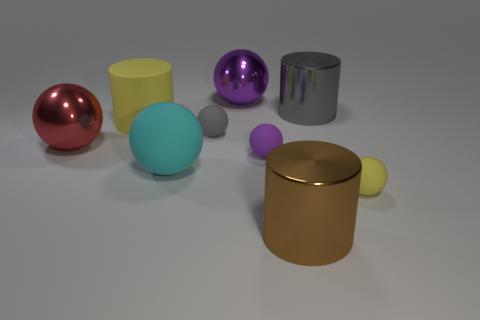Subtract all large rubber cylinders. How many cylinders are left? 2 Add 1 yellow matte things. How many objects exist? 10 Subtract 4 balls. How many balls are left? 2 Subtract all yellow cylinders. How many cylinders are left? 2 Subtract all cylinders. How many objects are left? 6 Subtract all green spheres. Subtract all gray cubes. How many spheres are left? 6 Subtract all brown spheres. How many purple cylinders are left? 0 Subtract all gray rubber cylinders. Subtract all large brown metallic cylinders. How many objects are left? 8 Add 5 tiny gray balls. How many tiny gray balls are left? 6 Add 4 tiny brown metal cubes. How many tiny brown metal cubes exist? 4 